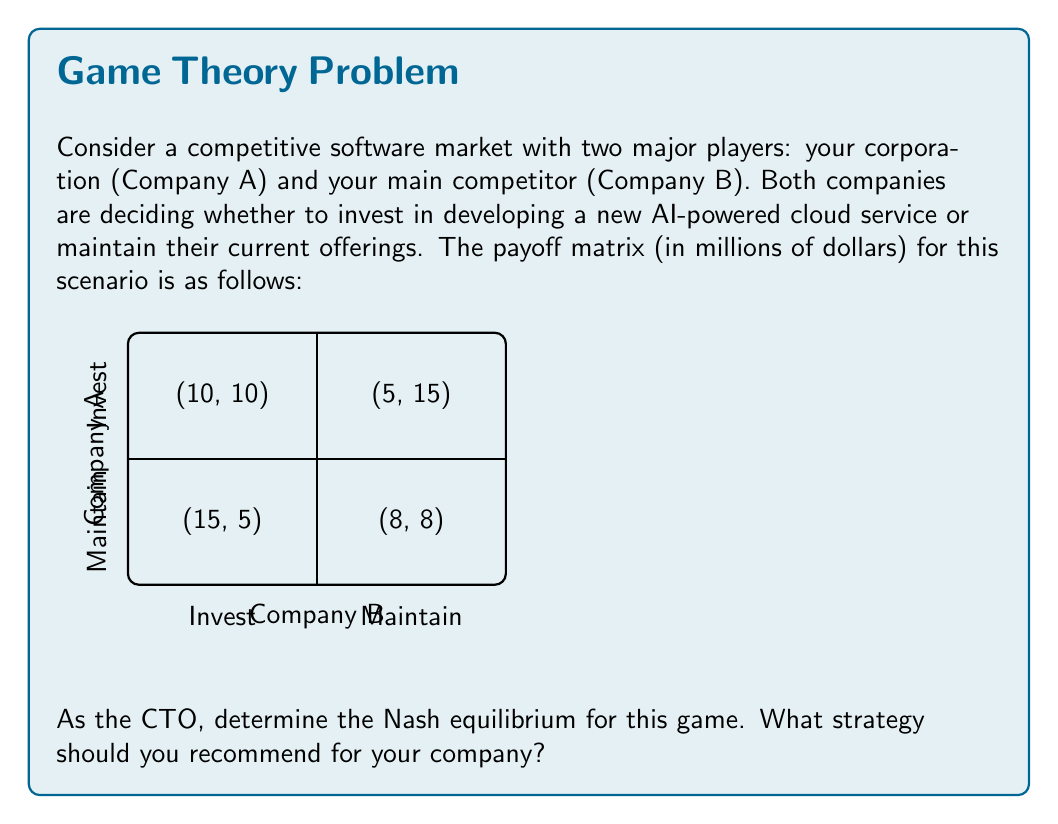Help me with this question. To find the Nash equilibrium, we need to analyze each player's best response to the other player's strategy. Let's approach this step-by-step:

1) First, let's consider Company A's strategies:
   - If B invests, A's best response is to invest (10 > 5)
   - If B maintains, A's best response is to invest (15 > 8)

2) Now, let's consider Company B's strategies:
   - If A invests, B's best response is to invest (10 > 5)
   - If A maintains, B's best response is to invest (15 > 8)

3) A Nash equilibrium occurs when both players are playing their best responses to each other's strategies. From our analysis, we can see that regardless of what the other company does, both companies' best strategy is to invest.

4) Therefore, the Nash equilibrium is (Invest, Invest), resulting in a payoff of (10, 10) for both companies.

5) To verify, let's check if any company has an incentive to deviate:
   - If A switches to Maintain while B invests, A's payoff decreases from 10 to 5
   - If B switches to Maintain while A invests, B's payoff decreases from 10 to 5

Neither company can improve their payoff by unilaterally changing their strategy, confirming that (Invest, Invest) is indeed a Nash equilibrium.

As the CTO, you should recommend the "Invest" strategy for your company. This strategy ensures the best outcome regardless of what your competitor does, and it aligns with the Nash equilibrium of the game.
Answer: (Invest, Invest) with payoffs (10, 10) 